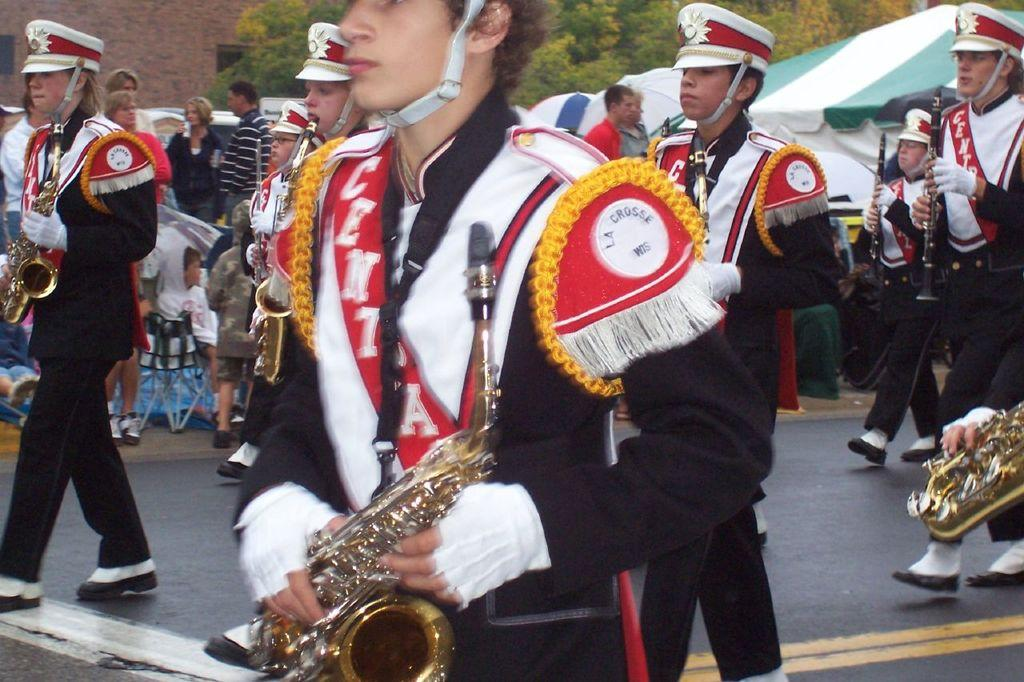What is happening on the road in the image? There is a group of people on the road. What are some of the people in the group doing? Some people in the group are holding musical instruments. What can be seen in the background of the image? There is a wall, a tent, trees, and some unspecified objects in the background of the image. Can you see a cub playing with a kitten near the tent in the image? No, there is no cub or kitten present in the image. Is there an oven visible in the background of the image? No, there is no oven visible in the image. 